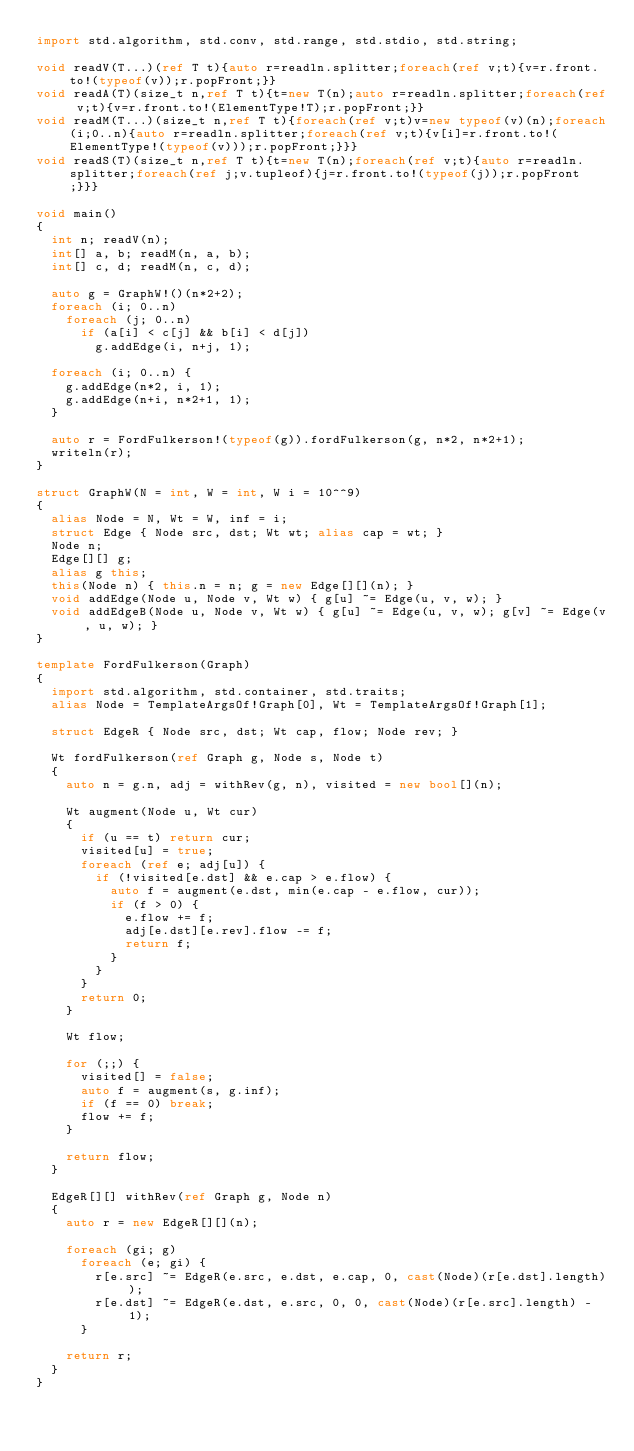Convert code to text. <code><loc_0><loc_0><loc_500><loc_500><_D_>import std.algorithm, std.conv, std.range, std.stdio, std.string;

void readV(T...)(ref T t){auto r=readln.splitter;foreach(ref v;t){v=r.front.to!(typeof(v));r.popFront;}}
void readA(T)(size_t n,ref T t){t=new T(n);auto r=readln.splitter;foreach(ref v;t){v=r.front.to!(ElementType!T);r.popFront;}}
void readM(T...)(size_t n,ref T t){foreach(ref v;t)v=new typeof(v)(n);foreach(i;0..n){auto r=readln.splitter;foreach(ref v;t){v[i]=r.front.to!(ElementType!(typeof(v)));r.popFront;}}}
void readS(T)(size_t n,ref T t){t=new T(n);foreach(ref v;t){auto r=readln.splitter;foreach(ref j;v.tupleof){j=r.front.to!(typeof(j));r.popFront;}}}

void main()
{
  int n; readV(n);
  int[] a, b; readM(n, a, b);
  int[] c, d; readM(n, c, d);

  auto g = GraphW!()(n*2+2);
  foreach (i; 0..n)
    foreach (j; 0..n)
      if (a[i] < c[j] && b[i] < d[j])
        g.addEdge(i, n+j, 1);

  foreach (i; 0..n) {
    g.addEdge(n*2, i, 1);
    g.addEdge(n+i, n*2+1, 1);
  }

  auto r = FordFulkerson!(typeof(g)).fordFulkerson(g, n*2, n*2+1);
  writeln(r);
}

struct GraphW(N = int, W = int, W i = 10^^9)
{
  alias Node = N, Wt = W, inf = i;
  struct Edge { Node src, dst; Wt wt; alias cap = wt; }
  Node n;
  Edge[][] g;
  alias g this;
  this(Node n) { this.n = n; g = new Edge[][](n); }
  void addEdge(Node u, Node v, Wt w) { g[u] ~= Edge(u, v, w); }
  void addEdgeB(Node u, Node v, Wt w) { g[u] ~= Edge(u, v, w); g[v] ~= Edge(v, u, w); }
}

template FordFulkerson(Graph)
{
  import std.algorithm, std.container, std.traits;
  alias Node = TemplateArgsOf!Graph[0], Wt = TemplateArgsOf!Graph[1];

  struct EdgeR { Node src, dst; Wt cap, flow; Node rev; }

  Wt fordFulkerson(ref Graph g, Node s, Node t)
  {
    auto n = g.n, adj = withRev(g, n), visited = new bool[](n);

    Wt augment(Node u, Wt cur)
    {
      if (u == t) return cur;
      visited[u] = true;
      foreach (ref e; adj[u]) {
        if (!visited[e.dst] && e.cap > e.flow) {
          auto f = augment(e.dst, min(e.cap - e.flow, cur));
          if (f > 0) {
            e.flow += f;
            adj[e.dst][e.rev].flow -= f;
            return f;
          }
        }
      }
      return 0;
    }

    Wt flow;

    for (;;) {
      visited[] = false;
      auto f = augment(s, g.inf);
      if (f == 0) break;
      flow += f;
    }

    return flow;
  }

  EdgeR[][] withRev(ref Graph g, Node n)
  {
    auto r = new EdgeR[][](n);

    foreach (gi; g)
      foreach (e; gi) {
        r[e.src] ~= EdgeR(e.src, e.dst, e.cap, 0, cast(Node)(r[e.dst].length));
        r[e.dst] ~= EdgeR(e.dst, e.src, 0, 0, cast(Node)(r[e.src].length) - 1);
      }

    return r;
  }
}
</code> 